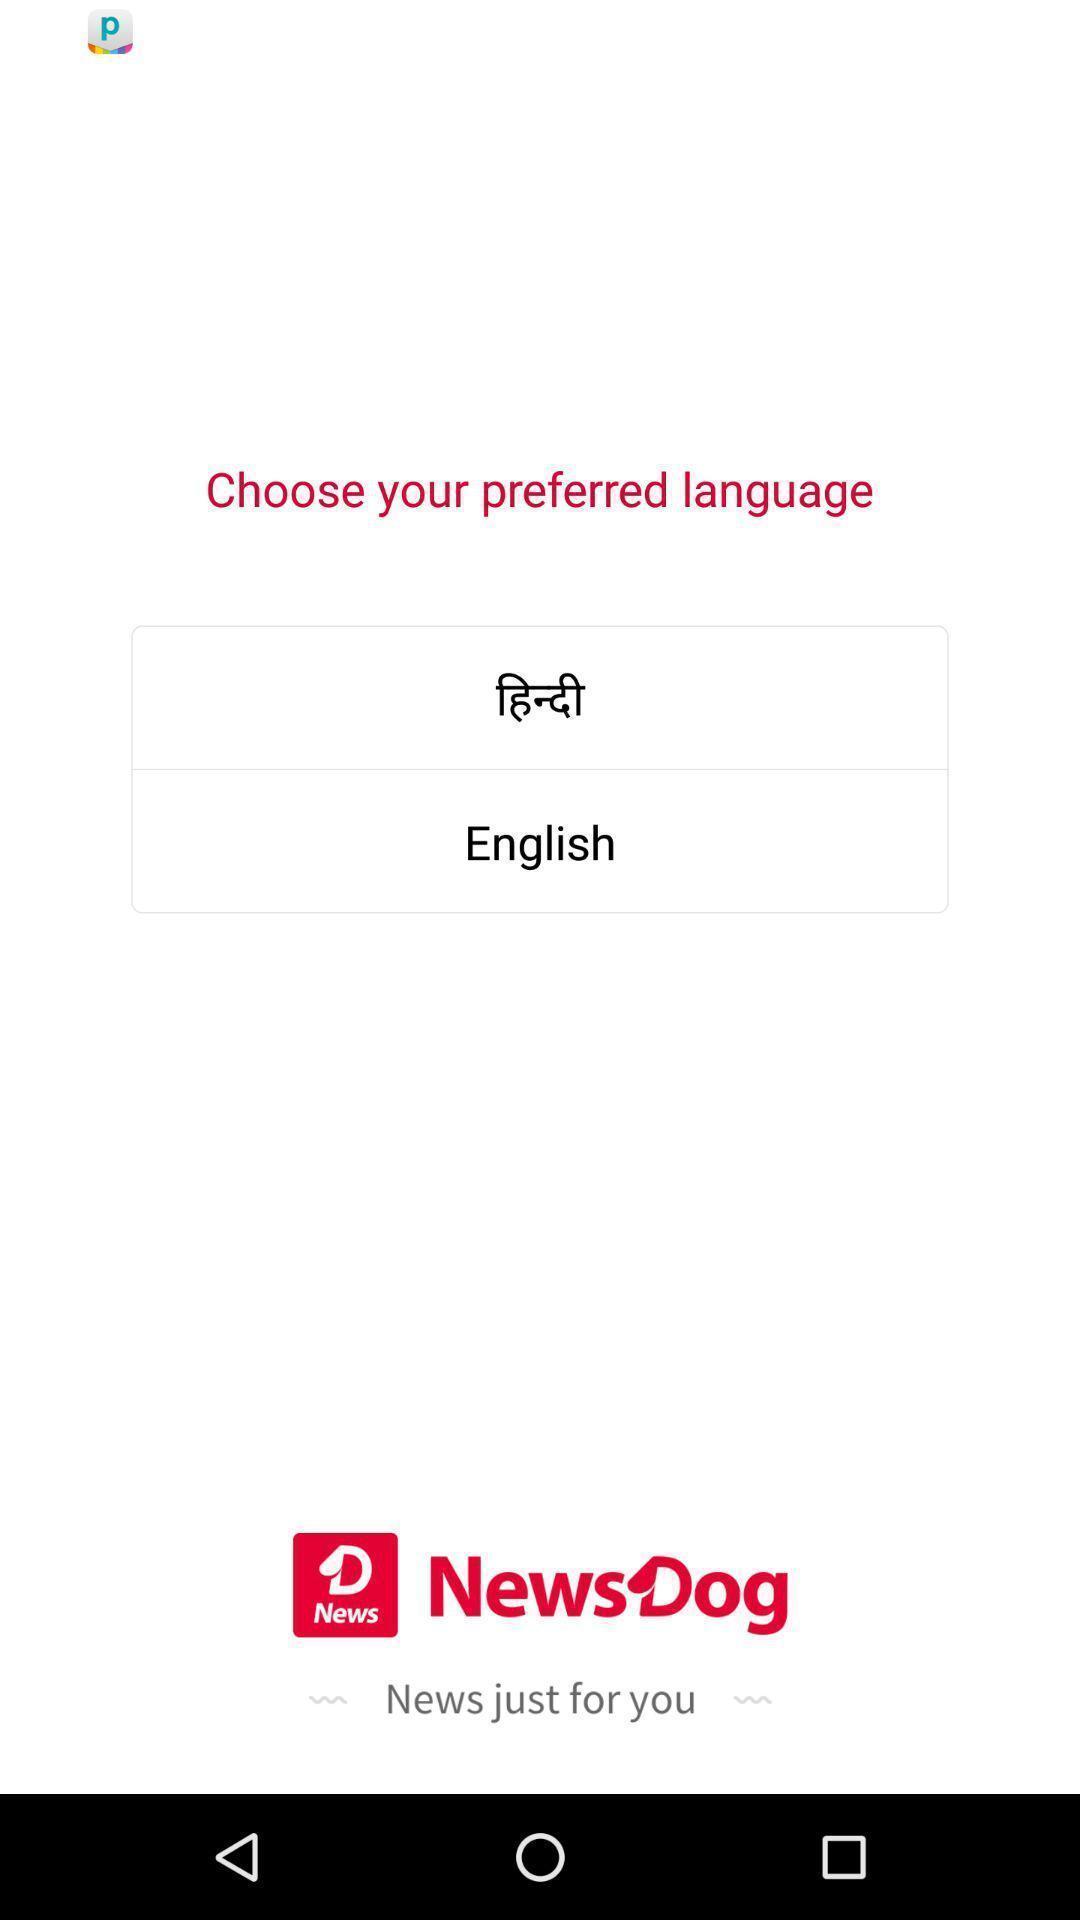What can you discern from this picture? Page with language option. 